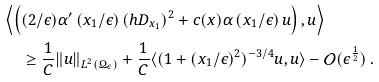Convert formula to latex. <formula><loc_0><loc_0><loc_500><loc_500>& \left \langle \left ( ( 2 / { \epsilon } ) \alpha ^ { \prime } \left ( { x _ { 1 } } / { \epsilon } \right ) ( h D _ { x _ { 1 } } ) ^ { 2 } + c ( x ) \alpha \left ( { x _ { 1 } } / { \epsilon } \right ) u \right ) , u \right \rangle \\ & \quad \ \geq \frac { 1 } { C } \| u \| _ { L ^ { 2 } ( \Omega _ { \epsilon } ) } + \frac { 1 } { C } \langle ( 1 + ( x _ { 1 } / \epsilon ) ^ { 2 } ) ^ { - 3 / 4 } u , u \rangle - { \mathcal { O } } ( \epsilon ^ { \frac { 1 } { 2 } } ) \, .</formula> 